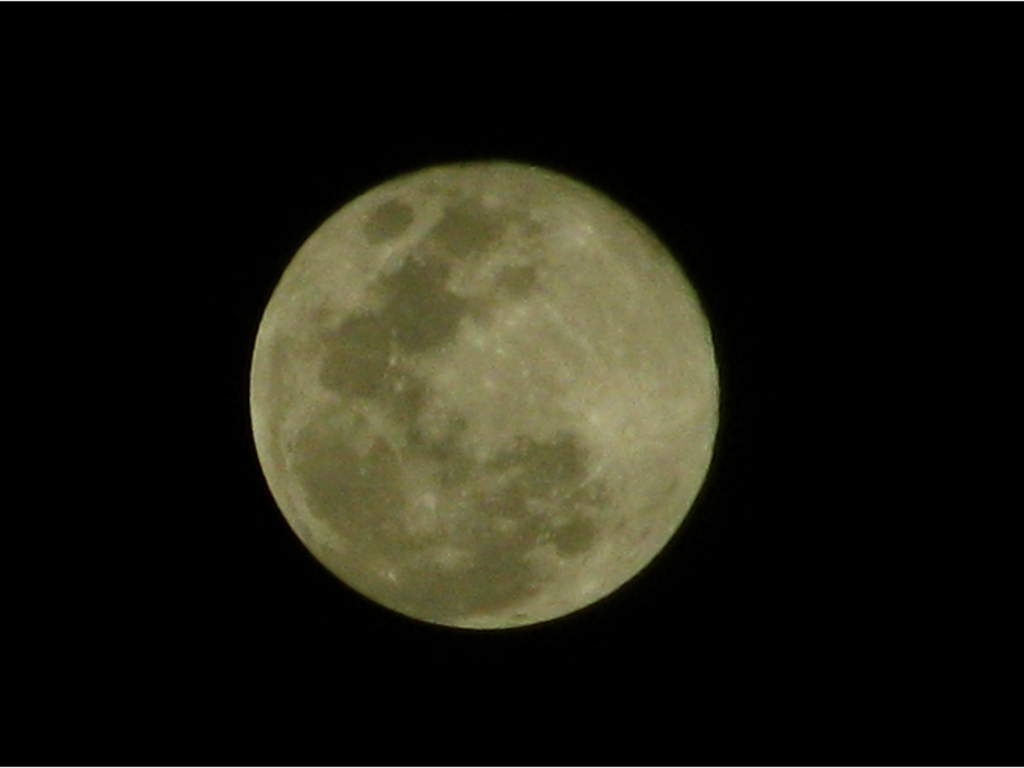What is the main subject of this image?
 The moon 